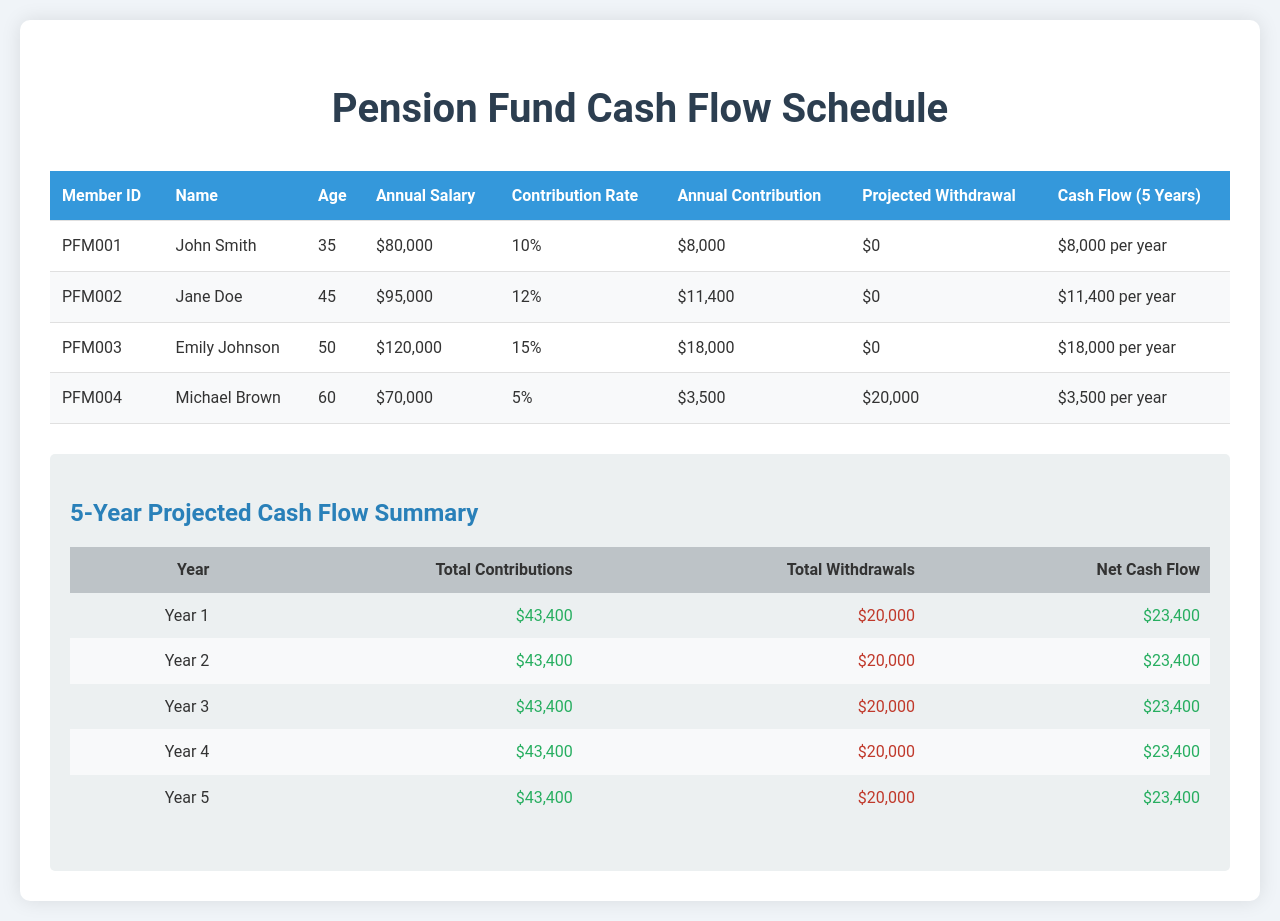What is the member ID of Jane Doe? The member ID is listed in the document under the "Member ID" column next to Jane Doe's name.
Answer: PFM002 What is John Smith's annual salary? John Smith's annual salary is provided in the "Annual Salary" column next to his name.
Answer: $80,000 How much does Emily Johnson contribute annually? The annual contribution amount is found in the "Annual Contribution" column next to Emily Johnson's name.
Answer: $18,000 What is the total amount projected to be withdrawn by Michael Brown? The projected withdrawal amount is specified in the "Projected Withdrawal" column for Michael Brown.
Answer: $20,000 What is the contribution rate for the pension fund members? The contribution rates are listed under the "Contribution Rate" column for each member, showing varying percentages.
Answer: 10%, 12%, 15%, 5% How many years is the cash flow schedule projected for? The document explicitly outlines the cash flow schedule over a specific timeframe.
Answer: 5 Years What is the net cash flow for Year 1? The net cash flow is calculated and presented in the summary table under the "Net Cash Flow" column for Year 1.
Answer: $23,400 Which member has the highest annual contribution? The highest amount of annual contribution is found in the corresponding member's row in the table.
Answer: Emily Johnson What color indicates contributions in the summary table? The color used to represent total contributions in the document is mentioned in the styling for net cash flow.
Answer: Positive (Green) 